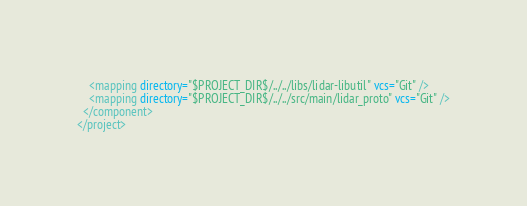Convert code to text. <code><loc_0><loc_0><loc_500><loc_500><_XML_>    <mapping directory="$PROJECT_DIR$/../../libs/lidar-libutil" vcs="Git" />
    <mapping directory="$PROJECT_DIR$/../../src/main/lidar_proto" vcs="Git" />
  </component>
</project></code> 